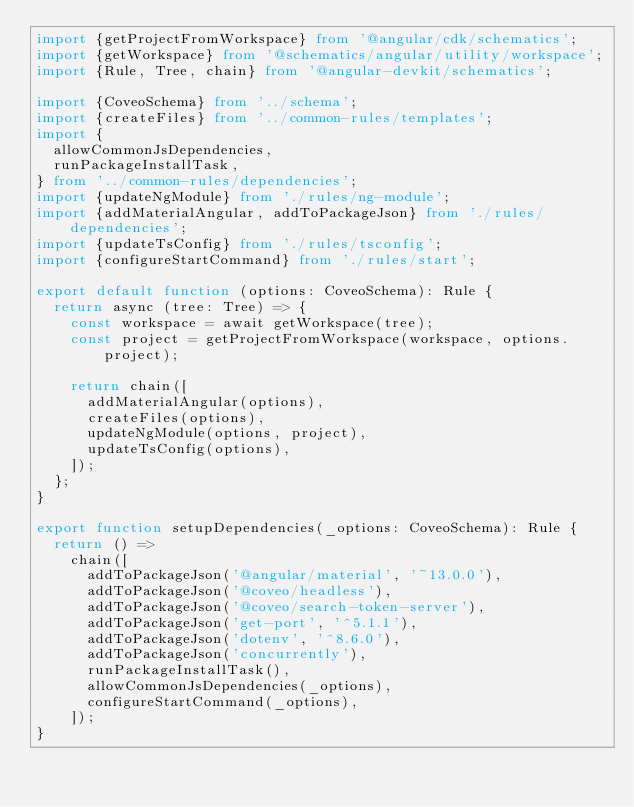<code> <loc_0><loc_0><loc_500><loc_500><_TypeScript_>import {getProjectFromWorkspace} from '@angular/cdk/schematics';
import {getWorkspace} from '@schematics/angular/utility/workspace';
import {Rule, Tree, chain} from '@angular-devkit/schematics';

import {CoveoSchema} from '../schema';
import {createFiles} from '../common-rules/templates';
import {
  allowCommonJsDependencies,
  runPackageInstallTask,
} from '../common-rules/dependencies';
import {updateNgModule} from './rules/ng-module';
import {addMaterialAngular, addToPackageJson} from './rules/dependencies';
import {updateTsConfig} from './rules/tsconfig';
import {configureStartCommand} from './rules/start';

export default function (options: CoveoSchema): Rule {
  return async (tree: Tree) => {
    const workspace = await getWorkspace(tree);
    const project = getProjectFromWorkspace(workspace, options.project);

    return chain([
      addMaterialAngular(options),
      createFiles(options),
      updateNgModule(options, project),
      updateTsConfig(options),
    ]);
  };
}

export function setupDependencies(_options: CoveoSchema): Rule {
  return () =>
    chain([
      addToPackageJson('@angular/material', '~13.0.0'),
      addToPackageJson('@coveo/headless'),
      addToPackageJson('@coveo/search-token-server'),
      addToPackageJson('get-port', '^5.1.1'),
      addToPackageJson('dotenv', '^8.6.0'),
      addToPackageJson('concurrently'),
      runPackageInstallTask(),
      allowCommonJsDependencies(_options),
      configureStartCommand(_options),
    ]);
}
</code> 